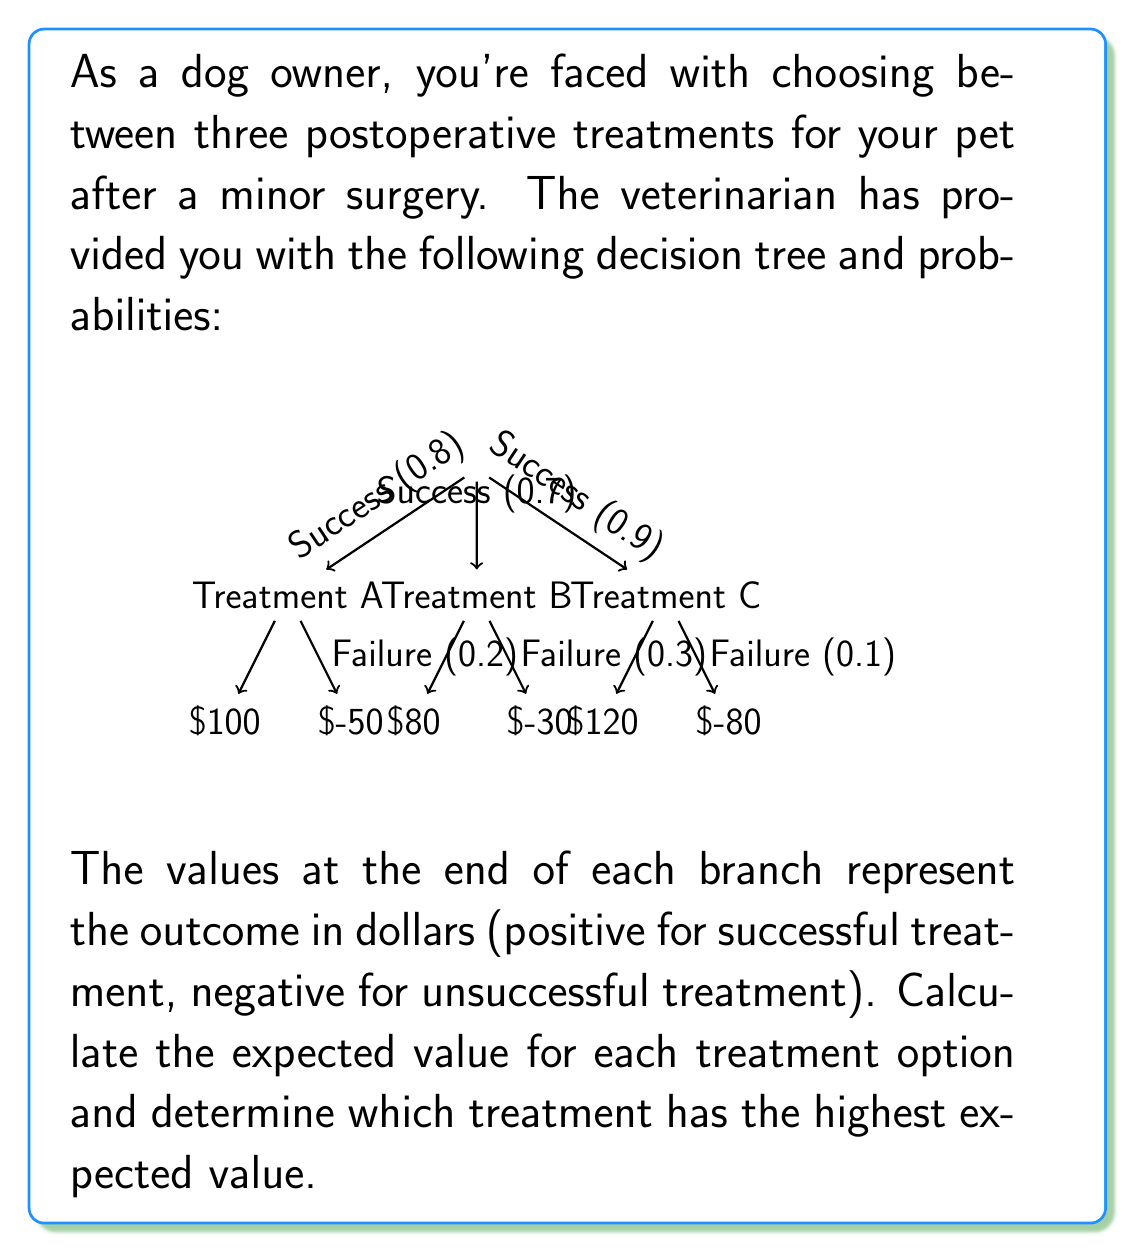What is the answer to this math problem? To solve this problem, we need to calculate the expected value for each treatment option using the given probabilities and outcomes. The expected value is the sum of each possible outcome multiplied by its probability.

For Treatment A:
$$ E(A) = 0.8 \times 100 + 0.2 \times (-50) = 80 - 10 = 70 $$

For Treatment B:
$$ E(B) = 0.7 \times 80 + 0.3 \times (-30) = 56 - 9 = 47 $$

For Treatment C:
$$ E(C) = 0.9 \times 120 + 0.1 \times (-80) = 108 - 8 = 100 $$

Now, we compare the expected values:

Treatment A: $70
Treatment B: $47
Treatment C: $100

The treatment with the highest expected value is Treatment C with $100.
Answer: The optimal decision is to choose Treatment C, which has the highest expected value of $100. 